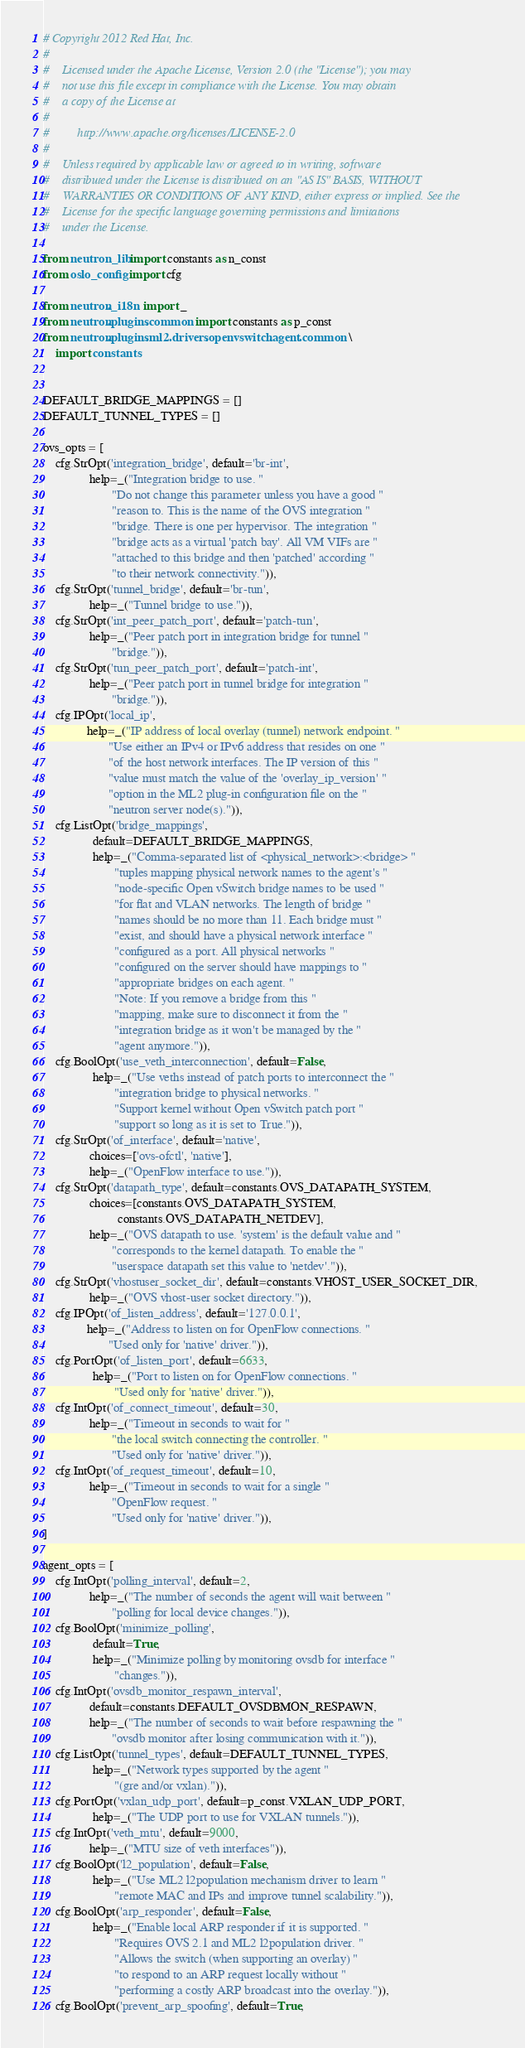<code> <loc_0><loc_0><loc_500><loc_500><_Python_># Copyright 2012 Red Hat, Inc.
#
#    Licensed under the Apache License, Version 2.0 (the "License"); you may
#    not use this file except in compliance with the License. You may obtain
#    a copy of the License at
#
#         http://www.apache.org/licenses/LICENSE-2.0
#
#    Unless required by applicable law or agreed to in writing, software
#    distributed under the License is distributed on an "AS IS" BASIS, WITHOUT
#    WARRANTIES OR CONDITIONS OF ANY KIND, either express or implied. See the
#    License for the specific language governing permissions and limitations
#    under the License.

from neutron_lib import constants as n_const
from oslo_config import cfg

from neutron._i18n import _
from neutron.plugins.common import constants as p_const
from neutron.plugins.ml2.drivers.openvswitch.agent.common \
    import constants


DEFAULT_BRIDGE_MAPPINGS = []
DEFAULT_TUNNEL_TYPES = []

ovs_opts = [
    cfg.StrOpt('integration_bridge', default='br-int',
               help=_("Integration bridge to use. "
                      "Do not change this parameter unless you have a good "
                      "reason to. This is the name of the OVS integration "
                      "bridge. There is one per hypervisor. The integration "
                      "bridge acts as a virtual 'patch bay'. All VM VIFs are "
                      "attached to this bridge and then 'patched' according "
                      "to their network connectivity.")),
    cfg.StrOpt('tunnel_bridge', default='br-tun',
               help=_("Tunnel bridge to use.")),
    cfg.StrOpt('int_peer_patch_port', default='patch-tun',
               help=_("Peer patch port in integration bridge for tunnel "
                      "bridge.")),
    cfg.StrOpt('tun_peer_patch_port', default='patch-int',
               help=_("Peer patch port in tunnel bridge for integration "
                      "bridge.")),
    cfg.IPOpt('local_ip',
              help=_("IP address of local overlay (tunnel) network endpoint. "
                     "Use either an IPv4 or IPv6 address that resides on one "
                     "of the host network interfaces. The IP version of this "
                     "value must match the value of the 'overlay_ip_version' "
                     "option in the ML2 plug-in configuration file on the "
                     "neutron server node(s).")),
    cfg.ListOpt('bridge_mappings',
                default=DEFAULT_BRIDGE_MAPPINGS,
                help=_("Comma-separated list of <physical_network>:<bridge> "
                       "tuples mapping physical network names to the agent's "
                       "node-specific Open vSwitch bridge names to be used "
                       "for flat and VLAN networks. The length of bridge "
                       "names should be no more than 11. Each bridge must "
                       "exist, and should have a physical network interface "
                       "configured as a port. All physical networks "
                       "configured on the server should have mappings to "
                       "appropriate bridges on each agent. "
                       "Note: If you remove a bridge from this "
                       "mapping, make sure to disconnect it from the "
                       "integration bridge as it won't be managed by the "
                       "agent anymore.")),
    cfg.BoolOpt('use_veth_interconnection', default=False,
                help=_("Use veths instead of patch ports to interconnect the "
                       "integration bridge to physical networks. "
                       "Support kernel without Open vSwitch patch port "
                       "support so long as it is set to True.")),
    cfg.StrOpt('of_interface', default='native',
               choices=['ovs-ofctl', 'native'],
               help=_("OpenFlow interface to use.")),
    cfg.StrOpt('datapath_type', default=constants.OVS_DATAPATH_SYSTEM,
               choices=[constants.OVS_DATAPATH_SYSTEM,
                        constants.OVS_DATAPATH_NETDEV],
               help=_("OVS datapath to use. 'system' is the default value and "
                      "corresponds to the kernel datapath. To enable the "
                      "userspace datapath set this value to 'netdev'.")),
    cfg.StrOpt('vhostuser_socket_dir', default=constants.VHOST_USER_SOCKET_DIR,
               help=_("OVS vhost-user socket directory.")),
    cfg.IPOpt('of_listen_address', default='127.0.0.1',
              help=_("Address to listen on for OpenFlow connections. "
                     "Used only for 'native' driver.")),
    cfg.PortOpt('of_listen_port', default=6633,
                help=_("Port to listen on for OpenFlow connections. "
                       "Used only for 'native' driver.")),
    cfg.IntOpt('of_connect_timeout', default=30,
               help=_("Timeout in seconds to wait for "
                      "the local switch connecting the controller. "
                      "Used only for 'native' driver.")),
    cfg.IntOpt('of_request_timeout', default=10,
               help=_("Timeout in seconds to wait for a single "
                      "OpenFlow request. "
                      "Used only for 'native' driver.")),
]

agent_opts = [
    cfg.IntOpt('polling_interval', default=2,
               help=_("The number of seconds the agent will wait between "
                      "polling for local device changes.")),
    cfg.BoolOpt('minimize_polling',
                default=True,
                help=_("Minimize polling by monitoring ovsdb for interface "
                       "changes.")),
    cfg.IntOpt('ovsdb_monitor_respawn_interval',
               default=constants.DEFAULT_OVSDBMON_RESPAWN,
               help=_("The number of seconds to wait before respawning the "
                      "ovsdb monitor after losing communication with it.")),
    cfg.ListOpt('tunnel_types', default=DEFAULT_TUNNEL_TYPES,
                help=_("Network types supported by the agent "
                       "(gre and/or vxlan).")),
    cfg.PortOpt('vxlan_udp_port', default=p_const.VXLAN_UDP_PORT,
                help=_("The UDP port to use for VXLAN tunnels.")),
    cfg.IntOpt('veth_mtu', default=9000,
               help=_("MTU size of veth interfaces")),
    cfg.BoolOpt('l2_population', default=False,
                help=_("Use ML2 l2population mechanism driver to learn "
                       "remote MAC and IPs and improve tunnel scalability.")),
    cfg.BoolOpt('arp_responder', default=False,
                help=_("Enable local ARP responder if it is supported. "
                       "Requires OVS 2.1 and ML2 l2population driver. "
                       "Allows the switch (when supporting an overlay) "
                       "to respond to an ARP request locally without "
                       "performing a costly ARP broadcast into the overlay.")),
    cfg.BoolOpt('prevent_arp_spoofing', default=True,</code> 